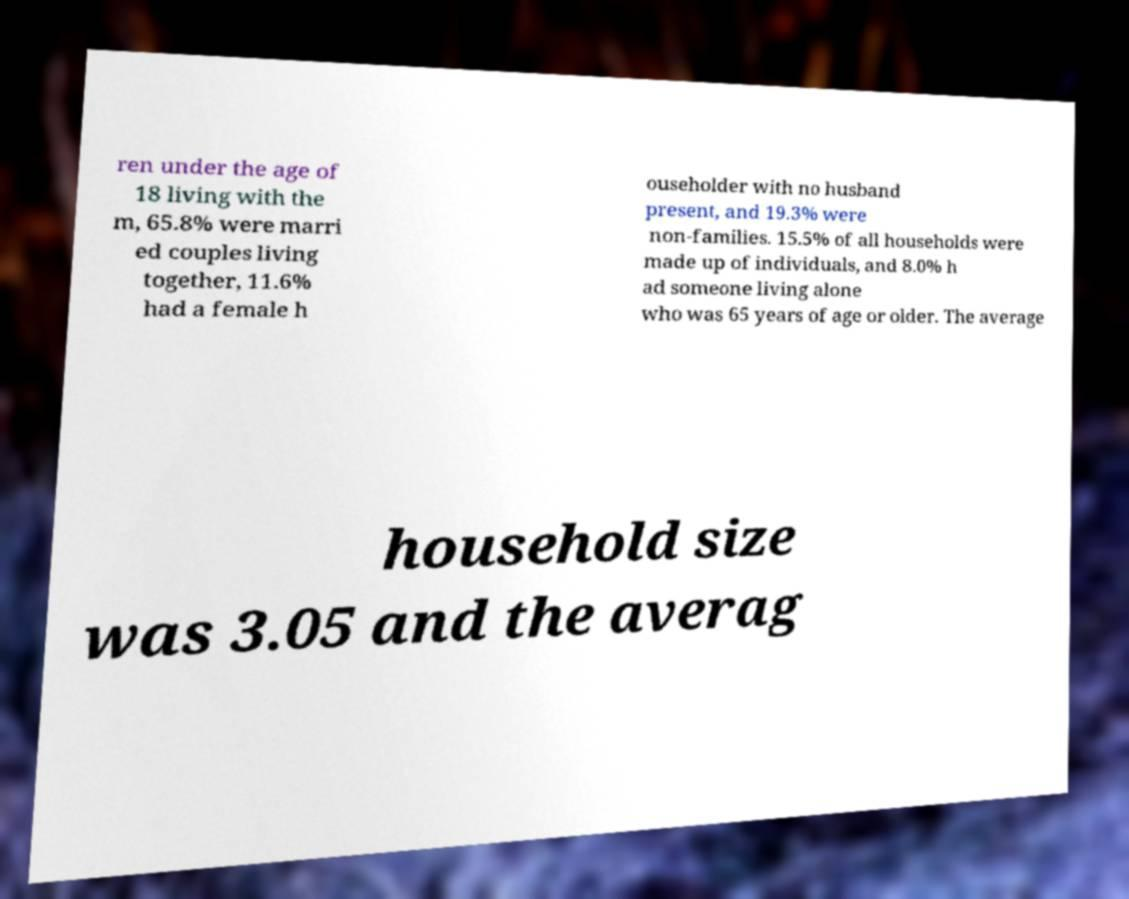Could you assist in decoding the text presented in this image and type it out clearly? ren under the age of 18 living with the m, 65.8% were marri ed couples living together, 11.6% had a female h ouseholder with no husband present, and 19.3% were non-families. 15.5% of all households were made up of individuals, and 8.0% h ad someone living alone who was 65 years of age or older. The average household size was 3.05 and the averag 